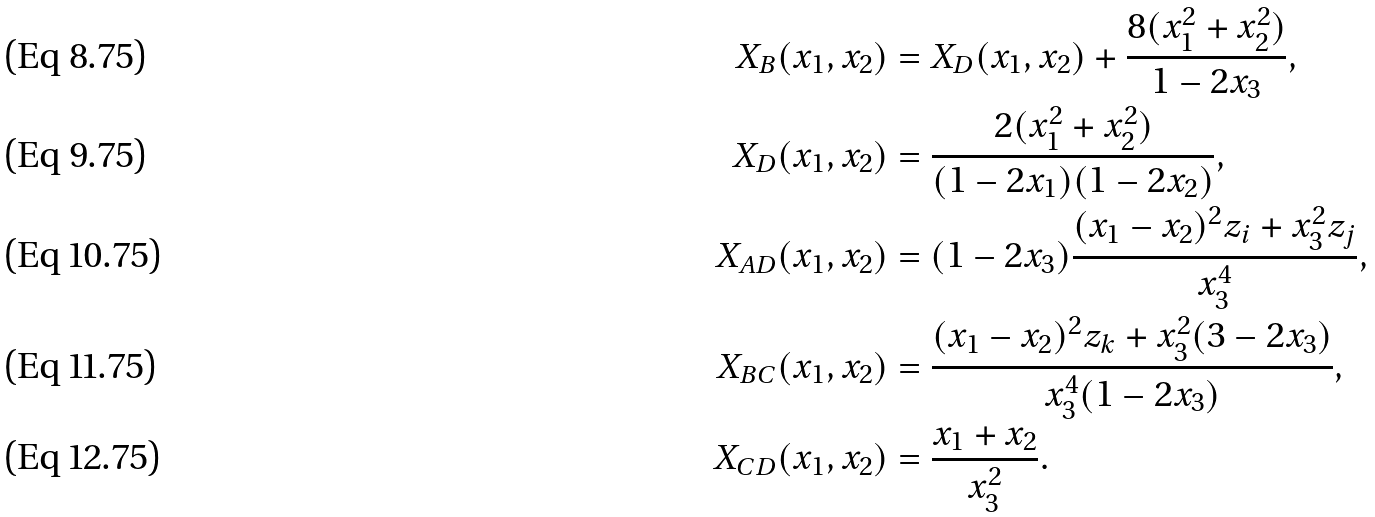Convert formula to latex. <formula><loc_0><loc_0><loc_500><loc_500>X _ { B } ( x _ { 1 } , x _ { 2 } ) & = X _ { D } ( x _ { 1 } , x _ { 2 } ) + \frac { 8 ( x _ { 1 } ^ { 2 } + x _ { 2 } ^ { 2 } ) } { 1 - 2 x _ { 3 } } , \\ X _ { D } ( x _ { 1 } , x _ { 2 } ) & = \frac { 2 ( x _ { 1 } ^ { 2 } + x _ { 2 } ^ { 2 } ) } { ( 1 - 2 x _ { 1 } ) ( 1 - 2 x _ { 2 } ) } , \\ X _ { A D } ( x _ { 1 } , x _ { 2 } ) & = ( 1 - 2 x _ { 3 } ) \frac { ( x _ { 1 } - x _ { 2 } ) ^ { 2 } z _ { i } + x _ { 3 } ^ { 2 } z _ { j } } { x _ { 3 } ^ { 4 } } , \\ X _ { B C } ( x _ { 1 } , x _ { 2 } ) & = \frac { ( x _ { 1 } - x _ { 2 } ) ^ { 2 } z _ { k } + x _ { 3 } ^ { 2 } ( 3 - 2 x _ { 3 } ) } { x _ { 3 } ^ { 4 } ( 1 - 2 x _ { 3 } ) } , \\ X _ { C D } ( x _ { 1 } , x _ { 2 } ) & = \frac { x _ { 1 } + x _ { 2 } } { x _ { 3 } ^ { 2 } } .</formula> 